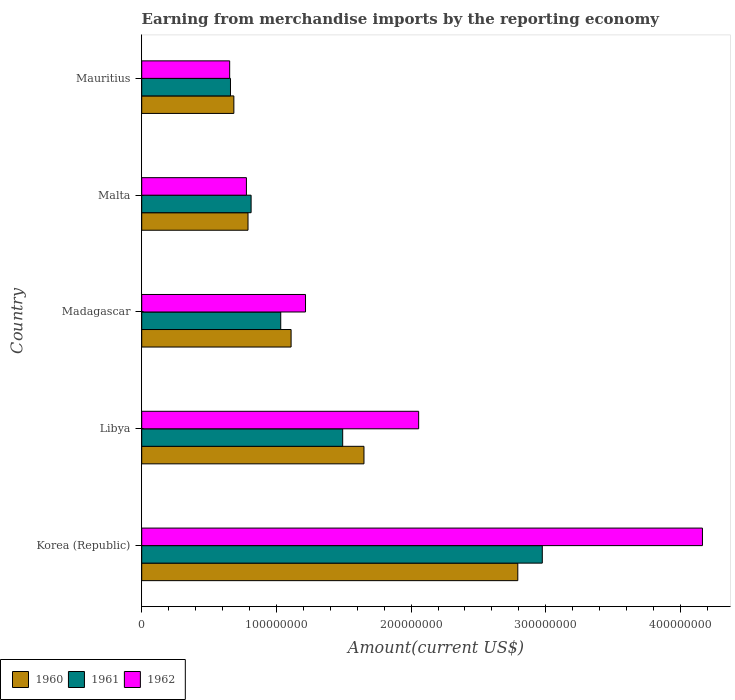How many bars are there on the 5th tick from the top?
Your answer should be compact. 3. How many bars are there on the 4th tick from the bottom?
Ensure brevity in your answer.  3. What is the label of the 4th group of bars from the top?
Your answer should be compact. Libya. In how many cases, is the number of bars for a given country not equal to the number of legend labels?
Ensure brevity in your answer.  0. What is the amount earned from merchandise imports in 1960 in Libya?
Provide a short and direct response. 1.65e+08. Across all countries, what is the maximum amount earned from merchandise imports in 1960?
Give a very brief answer. 2.79e+08. Across all countries, what is the minimum amount earned from merchandise imports in 1962?
Give a very brief answer. 6.53e+07. In which country was the amount earned from merchandise imports in 1960 maximum?
Ensure brevity in your answer.  Korea (Republic). In which country was the amount earned from merchandise imports in 1961 minimum?
Keep it short and to the point. Mauritius. What is the total amount earned from merchandise imports in 1961 in the graph?
Offer a terse response. 6.97e+08. What is the difference between the amount earned from merchandise imports in 1961 in Korea (Republic) and that in Malta?
Make the answer very short. 2.16e+08. What is the difference between the amount earned from merchandise imports in 1960 in Mauritius and the amount earned from merchandise imports in 1962 in Malta?
Provide a succinct answer. -9.33e+06. What is the average amount earned from merchandise imports in 1960 per country?
Offer a terse response. 1.40e+08. What is the difference between the amount earned from merchandise imports in 1961 and amount earned from merchandise imports in 1960 in Mauritius?
Give a very brief answer. -2.50e+06. In how many countries, is the amount earned from merchandise imports in 1961 greater than 140000000 US$?
Your answer should be compact. 2. What is the ratio of the amount earned from merchandise imports in 1962 in Libya to that in Mauritius?
Your answer should be compact. 3.15. What is the difference between the highest and the second highest amount earned from merchandise imports in 1962?
Ensure brevity in your answer.  2.11e+08. What is the difference between the highest and the lowest amount earned from merchandise imports in 1962?
Your answer should be compact. 3.51e+08. In how many countries, is the amount earned from merchandise imports in 1960 greater than the average amount earned from merchandise imports in 1960 taken over all countries?
Make the answer very short. 2. What does the 1st bar from the top in Korea (Republic) represents?
Offer a very short reply. 1962. Is it the case that in every country, the sum of the amount earned from merchandise imports in 1961 and amount earned from merchandise imports in 1960 is greater than the amount earned from merchandise imports in 1962?
Provide a succinct answer. Yes. Are all the bars in the graph horizontal?
Your response must be concise. Yes. Does the graph contain any zero values?
Keep it short and to the point. No. Where does the legend appear in the graph?
Keep it short and to the point. Bottom left. How are the legend labels stacked?
Provide a succinct answer. Horizontal. What is the title of the graph?
Your answer should be very brief. Earning from merchandise imports by the reporting economy. Does "1968" appear as one of the legend labels in the graph?
Give a very brief answer. No. What is the label or title of the X-axis?
Offer a very short reply. Amount(current US$). What is the label or title of the Y-axis?
Offer a very short reply. Country. What is the Amount(current US$) in 1960 in Korea (Republic)?
Your answer should be compact. 2.79e+08. What is the Amount(current US$) in 1961 in Korea (Republic)?
Offer a very short reply. 2.97e+08. What is the Amount(current US$) of 1962 in Korea (Republic)?
Keep it short and to the point. 4.16e+08. What is the Amount(current US$) of 1960 in Libya?
Keep it short and to the point. 1.65e+08. What is the Amount(current US$) of 1961 in Libya?
Keep it short and to the point. 1.49e+08. What is the Amount(current US$) of 1962 in Libya?
Your answer should be very brief. 2.06e+08. What is the Amount(current US$) in 1960 in Madagascar?
Make the answer very short. 1.11e+08. What is the Amount(current US$) of 1961 in Madagascar?
Ensure brevity in your answer.  1.03e+08. What is the Amount(current US$) of 1962 in Madagascar?
Offer a very short reply. 1.22e+08. What is the Amount(current US$) in 1960 in Malta?
Offer a very short reply. 7.89e+07. What is the Amount(current US$) of 1961 in Malta?
Make the answer very short. 8.12e+07. What is the Amount(current US$) in 1962 in Malta?
Provide a short and direct response. 7.77e+07. What is the Amount(current US$) in 1960 in Mauritius?
Make the answer very short. 6.84e+07. What is the Amount(current US$) in 1961 in Mauritius?
Your answer should be compact. 6.59e+07. What is the Amount(current US$) of 1962 in Mauritius?
Provide a succinct answer. 6.53e+07. Across all countries, what is the maximum Amount(current US$) in 1960?
Offer a terse response. 2.79e+08. Across all countries, what is the maximum Amount(current US$) in 1961?
Provide a succinct answer. 2.97e+08. Across all countries, what is the maximum Amount(current US$) in 1962?
Ensure brevity in your answer.  4.16e+08. Across all countries, what is the minimum Amount(current US$) of 1960?
Keep it short and to the point. 6.84e+07. Across all countries, what is the minimum Amount(current US$) of 1961?
Ensure brevity in your answer.  6.59e+07. Across all countries, what is the minimum Amount(current US$) of 1962?
Offer a terse response. 6.53e+07. What is the total Amount(current US$) of 1960 in the graph?
Keep it short and to the point. 7.02e+08. What is the total Amount(current US$) of 1961 in the graph?
Give a very brief answer. 6.97e+08. What is the total Amount(current US$) in 1962 in the graph?
Provide a succinct answer. 8.87e+08. What is the difference between the Amount(current US$) in 1960 in Korea (Republic) and that in Libya?
Ensure brevity in your answer.  1.14e+08. What is the difference between the Amount(current US$) in 1961 in Korea (Republic) and that in Libya?
Ensure brevity in your answer.  1.48e+08. What is the difference between the Amount(current US$) in 1962 in Korea (Republic) and that in Libya?
Keep it short and to the point. 2.11e+08. What is the difference between the Amount(current US$) of 1960 in Korea (Republic) and that in Madagascar?
Give a very brief answer. 1.68e+08. What is the difference between the Amount(current US$) in 1961 in Korea (Republic) and that in Madagascar?
Ensure brevity in your answer.  1.94e+08. What is the difference between the Amount(current US$) of 1962 in Korea (Republic) and that in Madagascar?
Your response must be concise. 2.95e+08. What is the difference between the Amount(current US$) of 1960 in Korea (Republic) and that in Malta?
Provide a short and direct response. 2.00e+08. What is the difference between the Amount(current US$) of 1961 in Korea (Republic) and that in Malta?
Ensure brevity in your answer.  2.16e+08. What is the difference between the Amount(current US$) in 1962 in Korea (Republic) and that in Malta?
Offer a very short reply. 3.39e+08. What is the difference between the Amount(current US$) in 1960 in Korea (Republic) and that in Mauritius?
Your answer should be compact. 2.11e+08. What is the difference between the Amount(current US$) of 1961 in Korea (Republic) and that in Mauritius?
Your response must be concise. 2.32e+08. What is the difference between the Amount(current US$) of 1962 in Korea (Republic) and that in Mauritius?
Give a very brief answer. 3.51e+08. What is the difference between the Amount(current US$) of 1960 in Libya and that in Madagascar?
Your response must be concise. 5.41e+07. What is the difference between the Amount(current US$) in 1961 in Libya and that in Madagascar?
Provide a succinct answer. 4.60e+07. What is the difference between the Amount(current US$) of 1962 in Libya and that in Madagascar?
Make the answer very short. 8.40e+07. What is the difference between the Amount(current US$) in 1960 in Libya and that in Malta?
Offer a very short reply. 8.61e+07. What is the difference between the Amount(current US$) in 1961 in Libya and that in Malta?
Offer a terse response. 6.80e+07. What is the difference between the Amount(current US$) of 1962 in Libya and that in Malta?
Keep it short and to the point. 1.28e+08. What is the difference between the Amount(current US$) of 1960 in Libya and that in Mauritius?
Ensure brevity in your answer.  9.66e+07. What is the difference between the Amount(current US$) in 1961 in Libya and that in Mauritius?
Offer a very short reply. 8.33e+07. What is the difference between the Amount(current US$) of 1962 in Libya and that in Mauritius?
Keep it short and to the point. 1.40e+08. What is the difference between the Amount(current US$) in 1960 in Madagascar and that in Malta?
Keep it short and to the point. 3.20e+07. What is the difference between the Amount(current US$) of 1961 in Madagascar and that in Malta?
Provide a succinct answer. 2.20e+07. What is the difference between the Amount(current US$) of 1962 in Madagascar and that in Malta?
Offer a very short reply. 4.39e+07. What is the difference between the Amount(current US$) of 1960 in Madagascar and that in Mauritius?
Make the answer very short. 4.25e+07. What is the difference between the Amount(current US$) of 1961 in Madagascar and that in Mauritius?
Offer a terse response. 3.73e+07. What is the difference between the Amount(current US$) of 1962 in Madagascar and that in Mauritius?
Keep it short and to the point. 5.63e+07. What is the difference between the Amount(current US$) in 1960 in Malta and that in Mauritius?
Ensure brevity in your answer.  1.05e+07. What is the difference between the Amount(current US$) of 1961 in Malta and that in Mauritius?
Give a very brief answer. 1.53e+07. What is the difference between the Amount(current US$) of 1962 in Malta and that in Mauritius?
Offer a very short reply. 1.24e+07. What is the difference between the Amount(current US$) of 1960 in Korea (Republic) and the Amount(current US$) of 1961 in Libya?
Offer a very short reply. 1.30e+08. What is the difference between the Amount(current US$) of 1960 in Korea (Republic) and the Amount(current US$) of 1962 in Libya?
Your answer should be very brief. 7.36e+07. What is the difference between the Amount(current US$) in 1961 in Korea (Republic) and the Amount(current US$) in 1962 in Libya?
Offer a very short reply. 9.18e+07. What is the difference between the Amount(current US$) of 1960 in Korea (Republic) and the Amount(current US$) of 1961 in Madagascar?
Your response must be concise. 1.76e+08. What is the difference between the Amount(current US$) of 1960 in Korea (Republic) and the Amount(current US$) of 1962 in Madagascar?
Your answer should be very brief. 1.58e+08. What is the difference between the Amount(current US$) in 1961 in Korea (Republic) and the Amount(current US$) in 1962 in Madagascar?
Make the answer very short. 1.76e+08. What is the difference between the Amount(current US$) of 1960 in Korea (Republic) and the Amount(current US$) of 1961 in Malta?
Give a very brief answer. 1.98e+08. What is the difference between the Amount(current US$) of 1960 in Korea (Republic) and the Amount(current US$) of 1962 in Malta?
Your response must be concise. 2.01e+08. What is the difference between the Amount(current US$) in 1961 in Korea (Republic) and the Amount(current US$) in 1962 in Malta?
Provide a short and direct response. 2.20e+08. What is the difference between the Amount(current US$) in 1960 in Korea (Republic) and the Amount(current US$) in 1961 in Mauritius?
Provide a short and direct response. 2.13e+08. What is the difference between the Amount(current US$) in 1960 in Korea (Republic) and the Amount(current US$) in 1962 in Mauritius?
Offer a terse response. 2.14e+08. What is the difference between the Amount(current US$) in 1961 in Korea (Republic) and the Amount(current US$) in 1962 in Mauritius?
Offer a terse response. 2.32e+08. What is the difference between the Amount(current US$) in 1960 in Libya and the Amount(current US$) in 1961 in Madagascar?
Provide a short and direct response. 6.18e+07. What is the difference between the Amount(current US$) in 1960 in Libya and the Amount(current US$) in 1962 in Madagascar?
Your answer should be compact. 4.34e+07. What is the difference between the Amount(current US$) in 1961 in Libya and the Amount(current US$) in 1962 in Madagascar?
Your answer should be very brief. 2.76e+07. What is the difference between the Amount(current US$) in 1960 in Libya and the Amount(current US$) in 1961 in Malta?
Make the answer very short. 8.38e+07. What is the difference between the Amount(current US$) of 1960 in Libya and the Amount(current US$) of 1962 in Malta?
Provide a succinct answer. 8.73e+07. What is the difference between the Amount(current US$) in 1961 in Libya and the Amount(current US$) in 1962 in Malta?
Give a very brief answer. 7.15e+07. What is the difference between the Amount(current US$) of 1960 in Libya and the Amount(current US$) of 1961 in Mauritius?
Ensure brevity in your answer.  9.91e+07. What is the difference between the Amount(current US$) of 1960 in Libya and the Amount(current US$) of 1962 in Mauritius?
Your response must be concise. 9.97e+07. What is the difference between the Amount(current US$) of 1961 in Libya and the Amount(current US$) of 1962 in Mauritius?
Offer a terse response. 8.39e+07. What is the difference between the Amount(current US$) in 1960 in Madagascar and the Amount(current US$) in 1961 in Malta?
Offer a very short reply. 2.97e+07. What is the difference between the Amount(current US$) in 1960 in Madagascar and the Amount(current US$) in 1962 in Malta?
Make the answer very short. 3.32e+07. What is the difference between the Amount(current US$) in 1961 in Madagascar and the Amount(current US$) in 1962 in Malta?
Make the answer very short. 2.55e+07. What is the difference between the Amount(current US$) in 1960 in Madagascar and the Amount(current US$) in 1961 in Mauritius?
Provide a short and direct response. 4.50e+07. What is the difference between the Amount(current US$) of 1960 in Madagascar and the Amount(current US$) of 1962 in Mauritius?
Your answer should be very brief. 4.56e+07. What is the difference between the Amount(current US$) in 1961 in Madagascar and the Amount(current US$) in 1962 in Mauritius?
Your response must be concise. 3.79e+07. What is the difference between the Amount(current US$) in 1960 in Malta and the Amount(current US$) in 1961 in Mauritius?
Give a very brief answer. 1.30e+07. What is the difference between the Amount(current US$) of 1960 in Malta and the Amount(current US$) of 1962 in Mauritius?
Make the answer very short. 1.36e+07. What is the difference between the Amount(current US$) in 1961 in Malta and the Amount(current US$) in 1962 in Mauritius?
Provide a short and direct response. 1.59e+07. What is the average Amount(current US$) of 1960 per country?
Offer a terse response. 1.40e+08. What is the average Amount(current US$) in 1961 per country?
Make the answer very short. 1.39e+08. What is the average Amount(current US$) of 1962 per country?
Make the answer very short. 1.77e+08. What is the difference between the Amount(current US$) of 1960 and Amount(current US$) of 1961 in Korea (Republic)?
Provide a short and direct response. -1.82e+07. What is the difference between the Amount(current US$) of 1960 and Amount(current US$) of 1962 in Korea (Republic)?
Your answer should be very brief. -1.37e+08. What is the difference between the Amount(current US$) in 1961 and Amount(current US$) in 1962 in Korea (Republic)?
Ensure brevity in your answer.  -1.19e+08. What is the difference between the Amount(current US$) of 1960 and Amount(current US$) of 1961 in Libya?
Keep it short and to the point. 1.58e+07. What is the difference between the Amount(current US$) in 1960 and Amount(current US$) in 1962 in Libya?
Your answer should be very brief. -4.06e+07. What is the difference between the Amount(current US$) in 1961 and Amount(current US$) in 1962 in Libya?
Give a very brief answer. -5.64e+07. What is the difference between the Amount(current US$) in 1960 and Amount(current US$) in 1961 in Madagascar?
Your answer should be compact. 7.70e+06. What is the difference between the Amount(current US$) of 1960 and Amount(current US$) of 1962 in Madagascar?
Provide a succinct answer. -1.07e+07. What is the difference between the Amount(current US$) of 1961 and Amount(current US$) of 1962 in Madagascar?
Provide a short and direct response. -1.84e+07. What is the difference between the Amount(current US$) in 1960 and Amount(current US$) in 1961 in Malta?
Offer a terse response. -2.30e+06. What is the difference between the Amount(current US$) of 1960 and Amount(current US$) of 1962 in Malta?
Provide a succinct answer. 1.18e+06. What is the difference between the Amount(current US$) in 1961 and Amount(current US$) in 1962 in Malta?
Your answer should be compact. 3.48e+06. What is the difference between the Amount(current US$) in 1960 and Amount(current US$) in 1961 in Mauritius?
Make the answer very short. 2.50e+06. What is the difference between the Amount(current US$) of 1960 and Amount(current US$) of 1962 in Mauritius?
Your answer should be very brief. 3.10e+06. What is the ratio of the Amount(current US$) of 1960 in Korea (Republic) to that in Libya?
Offer a terse response. 1.69. What is the ratio of the Amount(current US$) of 1961 in Korea (Republic) to that in Libya?
Provide a succinct answer. 1.99. What is the ratio of the Amount(current US$) of 1962 in Korea (Republic) to that in Libya?
Keep it short and to the point. 2.02. What is the ratio of the Amount(current US$) of 1960 in Korea (Republic) to that in Madagascar?
Your answer should be very brief. 2.52. What is the ratio of the Amount(current US$) of 1961 in Korea (Republic) to that in Madagascar?
Give a very brief answer. 2.88. What is the ratio of the Amount(current US$) in 1962 in Korea (Republic) to that in Madagascar?
Provide a short and direct response. 3.42. What is the ratio of the Amount(current US$) in 1960 in Korea (Republic) to that in Malta?
Make the answer very short. 3.54. What is the ratio of the Amount(current US$) in 1961 in Korea (Republic) to that in Malta?
Keep it short and to the point. 3.66. What is the ratio of the Amount(current US$) of 1962 in Korea (Republic) to that in Malta?
Your answer should be very brief. 5.36. What is the ratio of the Amount(current US$) of 1960 in Korea (Republic) to that in Mauritius?
Offer a terse response. 4.08. What is the ratio of the Amount(current US$) in 1961 in Korea (Republic) to that in Mauritius?
Your answer should be compact. 4.51. What is the ratio of the Amount(current US$) in 1962 in Korea (Republic) to that in Mauritius?
Offer a very short reply. 6.38. What is the ratio of the Amount(current US$) in 1960 in Libya to that in Madagascar?
Offer a terse response. 1.49. What is the ratio of the Amount(current US$) in 1961 in Libya to that in Madagascar?
Your answer should be very brief. 1.45. What is the ratio of the Amount(current US$) in 1962 in Libya to that in Madagascar?
Provide a short and direct response. 1.69. What is the ratio of the Amount(current US$) of 1960 in Libya to that in Malta?
Provide a short and direct response. 2.09. What is the ratio of the Amount(current US$) in 1961 in Libya to that in Malta?
Provide a succinct answer. 1.84. What is the ratio of the Amount(current US$) in 1962 in Libya to that in Malta?
Offer a very short reply. 2.65. What is the ratio of the Amount(current US$) of 1960 in Libya to that in Mauritius?
Your answer should be compact. 2.41. What is the ratio of the Amount(current US$) of 1961 in Libya to that in Mauritius?
Offer a very short reply. 2.26. What is the ratio of the Amount(current US$) of 1962 in Libya to that in Mauritius?
Give a very brief answer. 3.15. What is the ratio of the Amount(current US$) in 1960 in Madagascar to that in Malta?
Your answer should be compact. 1.41. What is the ratio of the Amount(current US$) of 1961 in Madagascar to that in Malta?
Give a very brief answer. 1.27. What is the ratio of the Amount(current US$) of 1962 in Madagascar to that in Malta?
Offer a very short reply. 1.56. What is the ratio of the Amount(current US$) of 1960 in Madagascar to that in Mauritius?
Offer a terse response. 1.62. What is the ratio of the Amount(current US$) of 1961 in Madagascar to that in Mauritius?
Ensure brevity in your answer.  1.57. What is the ratio of the Amount(current US$) in 1962 in Madagascar to that in Mauritius?
Your response must be concise. 1.86. What is the ratio of the Amount(current US$) of 1960 in Malta to that in Mauritius?
Ensure brevity in your answer.  1.15. What is the ratio of the Amount(current US$) in 1961 in Malta to that in Mauritius?
Provide a succinct answer. 1.23. What is the ratio of the Amount(current US$) of 1962 in Malta to that in Mauritius?
Your answer should be compact. 1.19. What is the difference between the highest and the second highest Amount(current US$) of 1960?
Ensure brevity in your answer.  1.14e+08. What is the difference between the highest and the second highest Amount(current US$) in 1961?
Your response must be concise. 1.48e+08. What is the difference between the highest and the second highest Amount(current US$) in 1962?
Keep it short and to the point. 2.11e+08. What is the difference between the highest and the lowest Amount(current US$) in 1960?
Offer a terse response. 2.11e+08. What is the difference between the highest and the lowest Amount(current US$) in 1961?
Your answer should be very brief. 2.32e+08. What is the difference between the highest and the lowest Amount(current US$) in 1962?
Provide a short and direct response. 3.51e+08. 